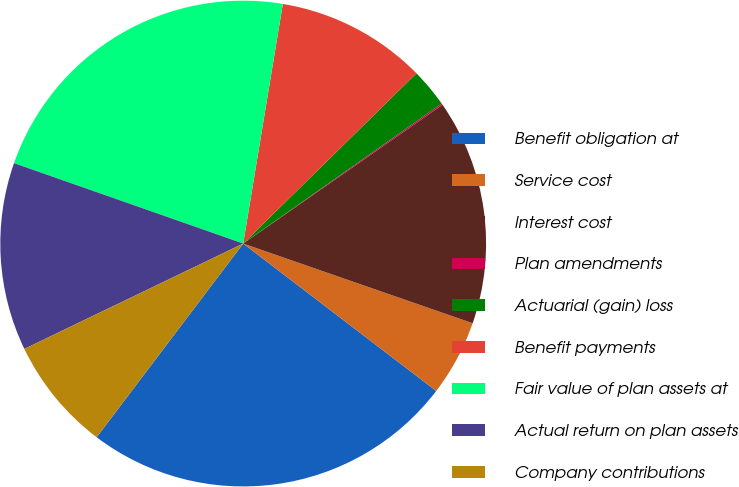<chart> <loc_0><loc_0><loc_500><loc_500><pie_chart><fcel>Benefit obligation at<fcel>Service cost<fcel>Interest cost<fcel>Plan amendments<fcel>Actuarial (gain) loss<fcel>Benefit payments<fcel>Fair value of plan assets at<fcel>Actual return on plan assets<fcel>Company contributions<nl><fcel>24.93%<fcel>5.06%<fcel>15.0%<fcel>0.1%<fcel>2.58%<fcel>10.03%<fcel>22.24%<fcel>12.51%<fcel>7.55%<nl></chart> 